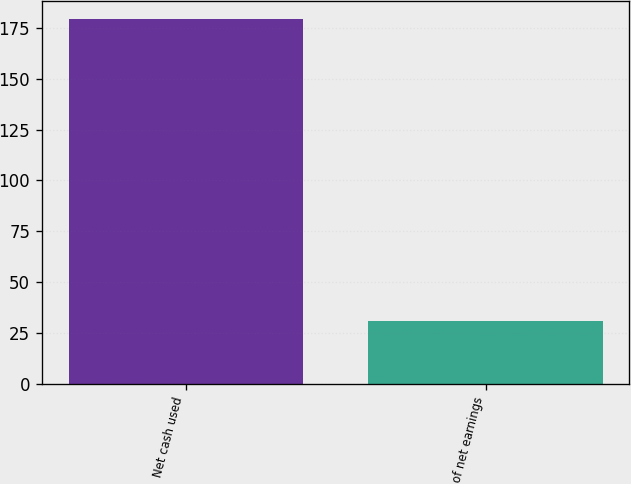Convert chart. <chart><loc_0><loc_0><loc_500><loc_500><bar_chart><fcel>Net cash used<fcel>of net earnings<nl><fcel>179.3<fcel>31<nl></chart> 